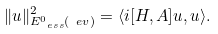<formula> <loc_0><loc_0><loc_500><loc_500>\| u \| _ { E _ { \ e s s } ^ { 0 } ( \ e v ) } ^ { 2 } = \langle i [ H , A ] u , u \rangle .</formula> 